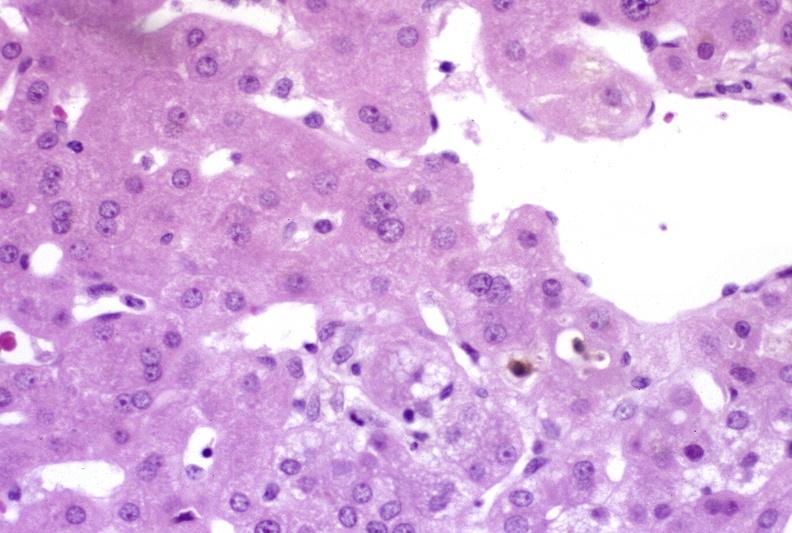s liver present?
Answer the question using a single word or phrase. Yes 